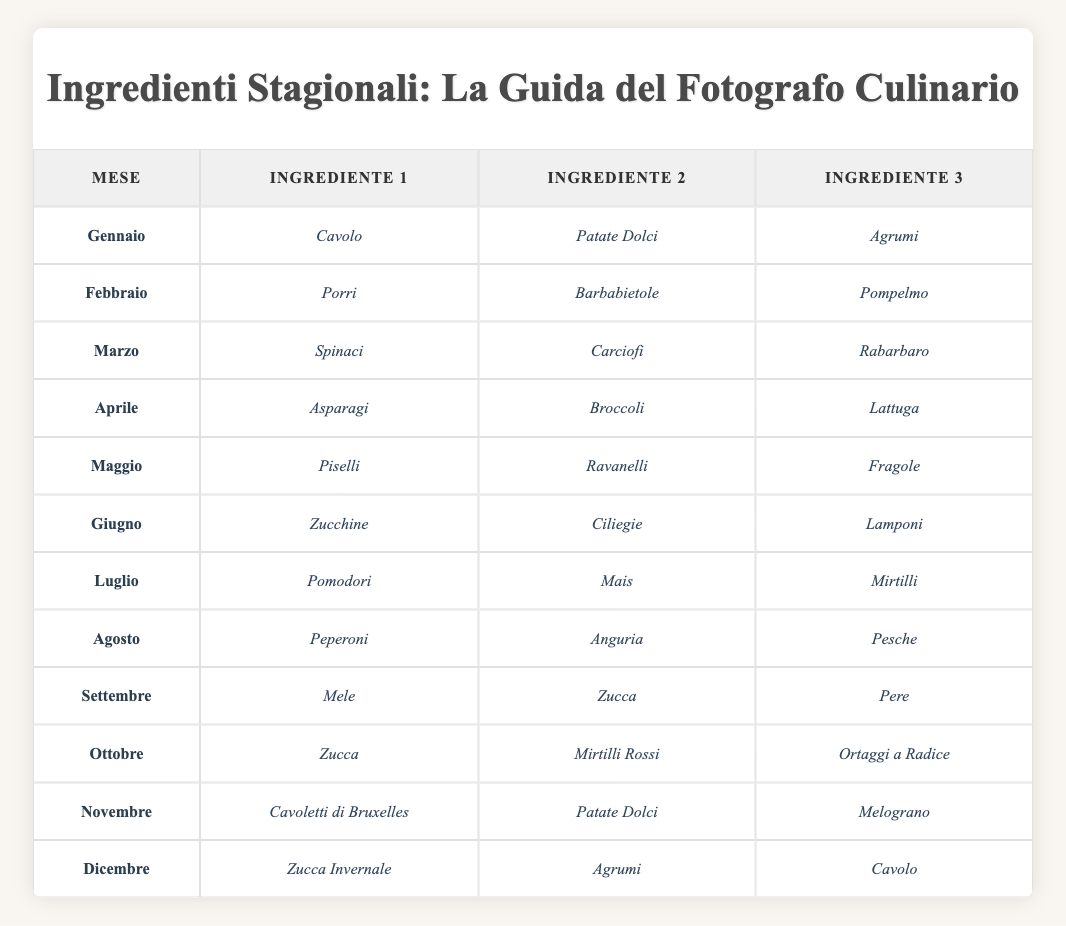Quali sono gli ingredienti stagionali di luglio? Secondo la tabella, gli ingredienti stagionali per il mese di luglio sono Pomodori, Mais e Mirtilli.
Answer: Pomodori, Mais, Mirtilli In quale mese si trovano le fragole? Guardando nella tabella, le fragole sono elencate nel mese di maggio.
Answer: Maggio Il pompelmo è un ingrediente stagionale a febbraio? La tabella mostra che il pompelmo è elencato per il mese di febbraio.
Answer: Sì Quali sono gli ingredienti stagionali per autunno (settembre, ottobre, novembre)? Per settembre gli ingredienti sono Mele, Zucca e Pere; per ottobre sono Zucca, Mirtilli Rossi e Ortaggi a Radice; per novembre sono Cavoletti di Bruxelles, Patate Dolci e Melograno. Sommandoli otteniamo un totale di 9 ingredienti.
Answer: Mele, Zucca, Pere, Zucca, Mirtilli Rossi, Ortaggi a Radice, Cavoletti di Bruxelles, Patate Dolci, Melograno Qual è l'ingrediente che appare sia a gennaio che a novembre? Controllando i due mesi, l'ingrediente comune è Patate Dolci.
Answer: Patate Dolci Qual è il mese in cui si possono trovare le zucchine? Nella tabella, le zucchine risultano disponibili nel mese di giugno.
Answer: Giugno Quante verdure a foglia verde compaiono nella lista? Le verdure a foglia verde nella lista sono Kale, Spinaci, Broccoli e Lattuga, per un totale di 4.
Answer: 4 Durante quali mesi è presente il cavolo? Guardando la tabella, il cavolo è presente a gennaio e dicembre.
Answer: Gennaio, Dicembre Qual è l'ingrediente in comune tra marzo e aprile? Analizzando i due mesi, non ci sono ingredienti in comune tra marzo (Spinaci, Carciofi, Rabarbaro) e aprile (Asparagi, Broccoli, Lattuga).
Answer: Nessuno 